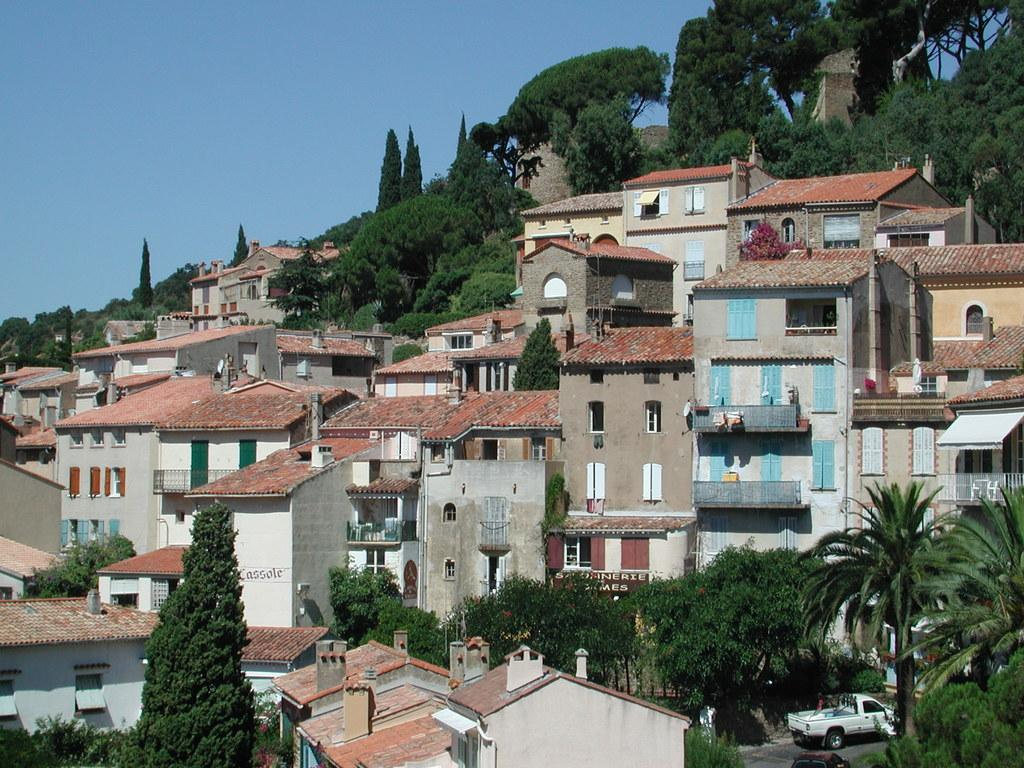What type of structures can be seen in the image? There are buildings in the image. What type of vegetation is present in the image? There are trees in the image. What type of coal can be seen in the image? There is no coal present in the image. What advice is given by the trees in the image? The trees in the image do not give any advice, as they are inanimate objects. 